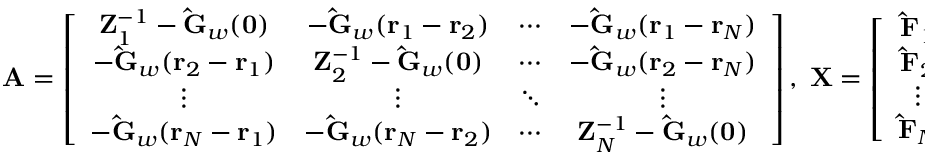<formula> <loc_0><loc_0><loc_500><loc_500>A = \left [ \begin{array} { c c c c } { { Z _ { 1 } ^ { - 1 } - \hat { G } _ { w } ( 0 ) } } & { { - \hat { G } _ { w } ( r _ { 1 } - r _ { 2 } ) } } & { \cdots } & { { - \hat { G } _ { w } ( r _ { 1 } - r _ { N } ) } } \\ { { - \hat { G } _ { w } ( r _ { 2 } - r _ { 1 } ) } } & { { Z _ { 2 } ^ { - 1 } - \hat { G } _ { w } ( 0 ) } } & { \cdots } & { { - \hat { G } _ { w } ( r _ { 2 } - r _ { N } ) } } \\ { \vdots } & { \vdots } & { \ddots } & { \vdots } \\ { { - \hat { G } _ { w } ( r _ { N } - r _ { 1 } ) } } & { { - \hat { G } _ { w } ( r _ { N } - r _ { 2 } ) } } & { \cdots } & { { Z _ { N } ^ { - 1 } - \hat { G } _ { w } ( 0 ) } } \end{array} \right ] , \, X = \left [ \begin{array} { c } { { \hat { F } _ { 1 } } } \\ { { \hat { F } _ { 2 } } } \\ { \vdots } \\ { { \hat { F } _ { N } } } \end{array} \right ] , \, B = \left [ \begin{array} { c } { { \hat { w } _ { 0 } ( r _ { 1 } ) } } \\ { { \hat { w } _ { 0 } ( r _ { 2 } ) } } \\ { \vdots } \\ { { \hat { w } _ { 0 } ( r _ { N } ) } } \end{array} \right ] .</formula> 